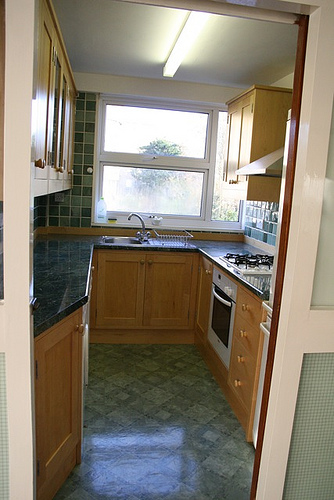What is this photo about? This photo captures a cozy kitchen featuring multiple wooden cabinets throughout the space. On the left side of the image, there's a tall cabinet that stretches almost to the ceiling. Below a large window, there's a countertop with a sink and faucet. The center area showcases both upper and lower cabinets, with a stove and oven nestled in between. A solitary bottle is visible on the countertop, adding a personal touch. The kitchen's layout appears efficient and functional, making the most of the available space. 